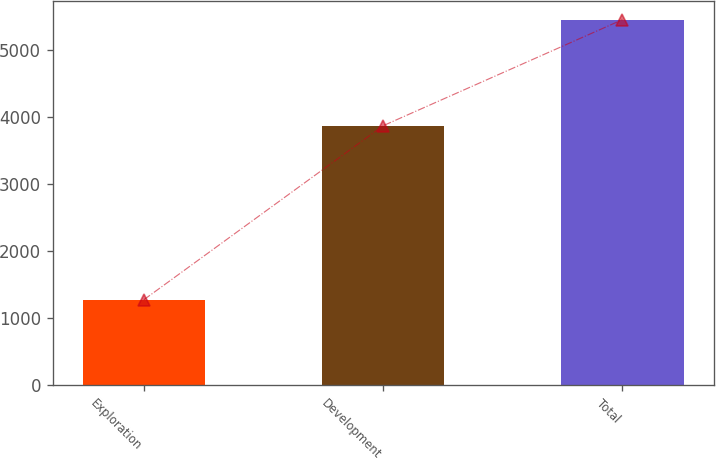<chart> <loc_0><loc_0><loc_500><loc_500><bar_chart><fcel>Exploration<fcel>Development<fcel>Total<nl><fcel>1271<fcel>3868<fcel>5451<nl></chart> 